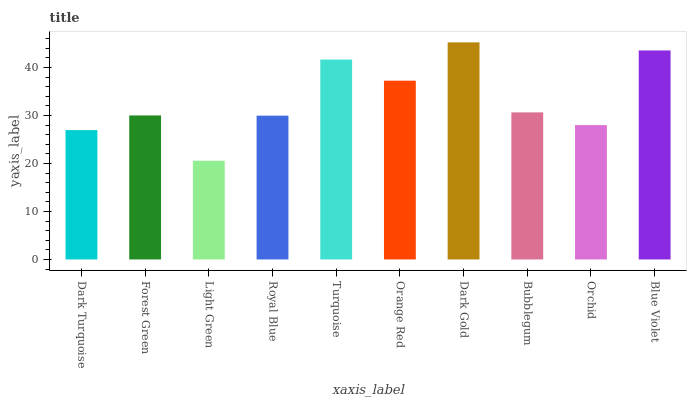Is Light Green the minimum?
Answer yes or no. Yes. Is Dark Gold the maximum?
Answer yes or no. Yes. Is Forest Green the minimum?
Answer yes or no. No. Is Forest Green the maximum?
Answer yes or no. No. Is Forest Green greater than Dark Turquoise?
Answer yes or no. Yes. Is Dark Turquoise less than Forest Green?
Answer yes or no. Yes. Is Dark Turquoise greater than Forest Green?
Answer yes or no. No. Is Forest Green less than Dark Turquoise?
Answer yes or no. No. Is Bubblegum the high median?
Answer yes or no. Yes. Is Forest Green the low median?
Answer yes or no. Yes. Is Light Green the high median?
Answer yes or no. No. Is Bubblegum the low median?
Answer yes or no. No. 